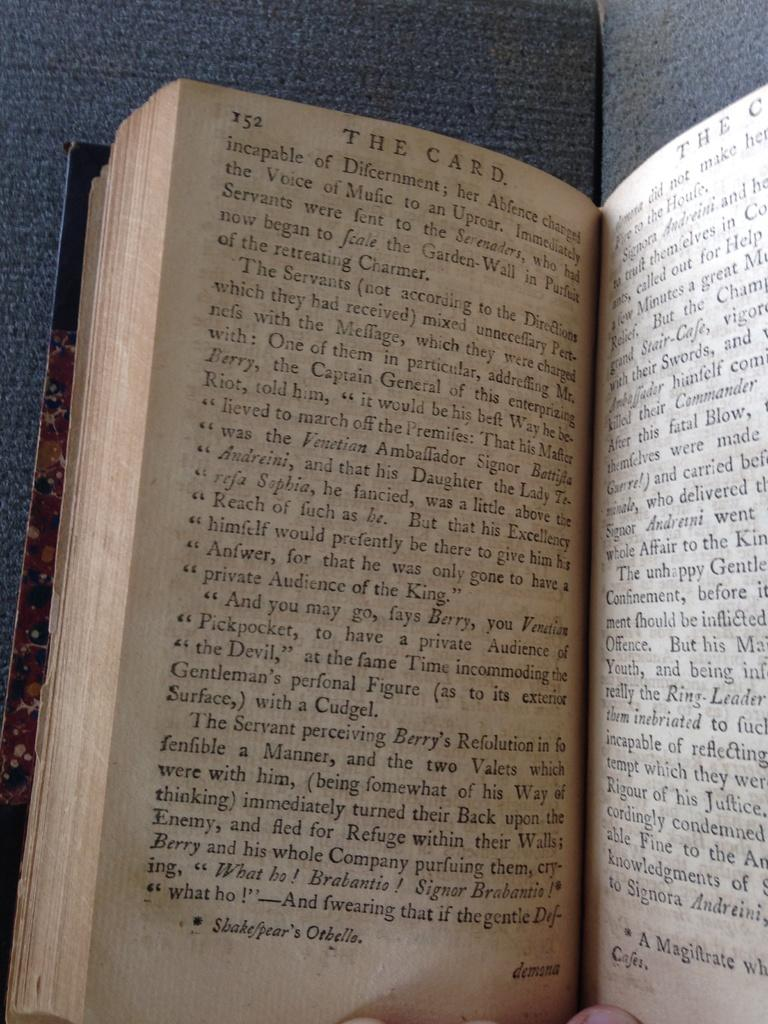Provide a one-sentence caption for the provided image. A person holding an open book called The Card. 